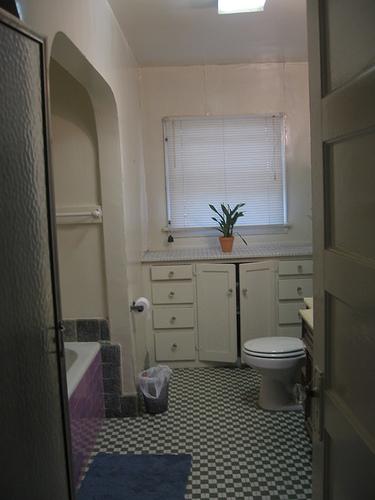Is this a finished room?
Short answer required. Yes. Where is the plant?
Keep it brief. Counter. Is the window blind closed?
Quick response, please. Yes. Is this a nice bathroom?
Give a very brief answer. Yes. Is the light bulb on the ceiling on or off?
Keep it brief. On. What color is the tub?
Answer briefly. Purple. What many drawers?
Be succinct. 8. How many handles does the drawer have?
Keep it brief. 1. Is this room tidy?
Be succinct. Yes. What is hanging on the cabinet?
Concise answer only. Plant. Is this the kitchen area?
Give a very brief answer. No. What is leaning against the wall under the window?
Keep it brief. Plant. What color is the floor?
Quick response, please. Black and white. Is the shade down?
Be succinct. Yes. Is this room dirty or clean?
Be succinct. Clean. Is there a television visible in the picture?
Give a very brief answer. No. Is this a throne for a queen?
Write a very short answer. No. What would a person put on the shelves on the left?
Answer briefly. Towels. Is the tiled area a headboard?
Write a very short answer. No. Where is the towel?
Be succinct. No towel. Where is the trashcan?
Keep it brief. Under toilet paper. Does this bathroom have a tub?
Give a very brief answer. Yes. Is there a thermostat on the wall?
Keep it brief. No. Is there toothpaste in the picture?
Short answer required. No. What color is the carpet?
Concise answer only. Blue. How many TVs are visible?
Concise answer only. 0. What is different about the bathtub?
Give a very brief answer. Purple. Is there a shower curtain?
Keep it brief. No. Is this in a house?
Be succinct. Yes. How many light sources are in the room?
Answer briefly. 1. Are these new hardwood floors?
Short answer required. No. What color is the trash can?
Quick response, please. Gray. What is on the floor?
Quick response, please. Rug. What room is this?
Answer briefly. Bathroom. Is the stepladder blocking the toilet?
Answer briefly. No. What color is the floor mat?
Concise answer only. Blue. What room of the house is this?
Write a very short answer. Bathroom. Are the blinds open?
Concise answer only. No. Is there sun coming through the window?
Answer briefly. No. Could you reach more toilet paper without standing up?
Give a very brief answer. No. What color is the counter?
Write a very short answer. White. Is this home finished?
Short answer required. Yes. What color is the rug?
Write a very short answer. Blue. Is there a reflection in the mirror?
Write a very short answer. No. What kind of floor is pictured?
Quick response, please. Tile. Is the floor wooden or carpeted in this picture?
Concise answer only. Carpeted. What kind of person lives here?
Give a very brief answer. Neat. What color is the basket?
Keep it brief. Black. How many draws are in the cabinet?
Keep it brief. 8. Is there a live plant next to the wall?
Short answer required. Yes. What type of room do you think this is?
Concise answer only. Bathroom. Would you use the bathroom here?
Keep it brief. Yes. How many diamond shapes are in pattern on the floor?
Be succinct. 100. What is the ring on the left wall for?
Concise answer only. Toilet paper. Is the lid up or down?
Concise answer only. Down. Is the chair in front of the door?
Quick response, please. No. How many rolls of toilet paper can be seen?
Be succinct. 1. Is this bathroom filthy?
Write a very short answer. No. Is the toilet paper empty?
Be succinct. No. 